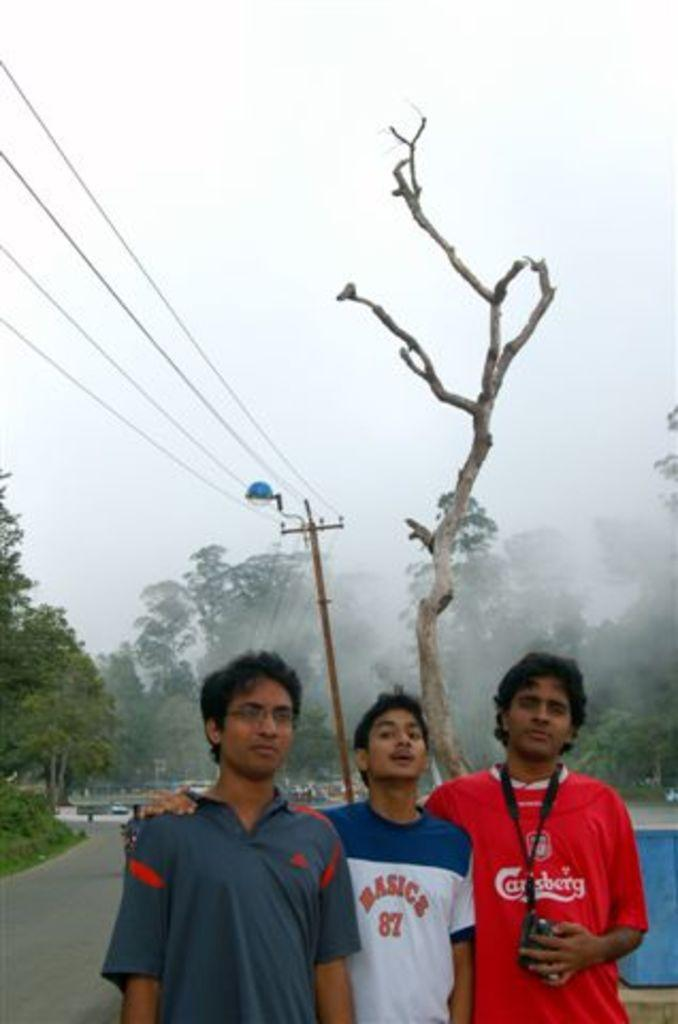<image>
Offer a succinct explanation of the picture presented. A young man wearing a Carlsberg Beer t-shirt poses with two of his friends. 